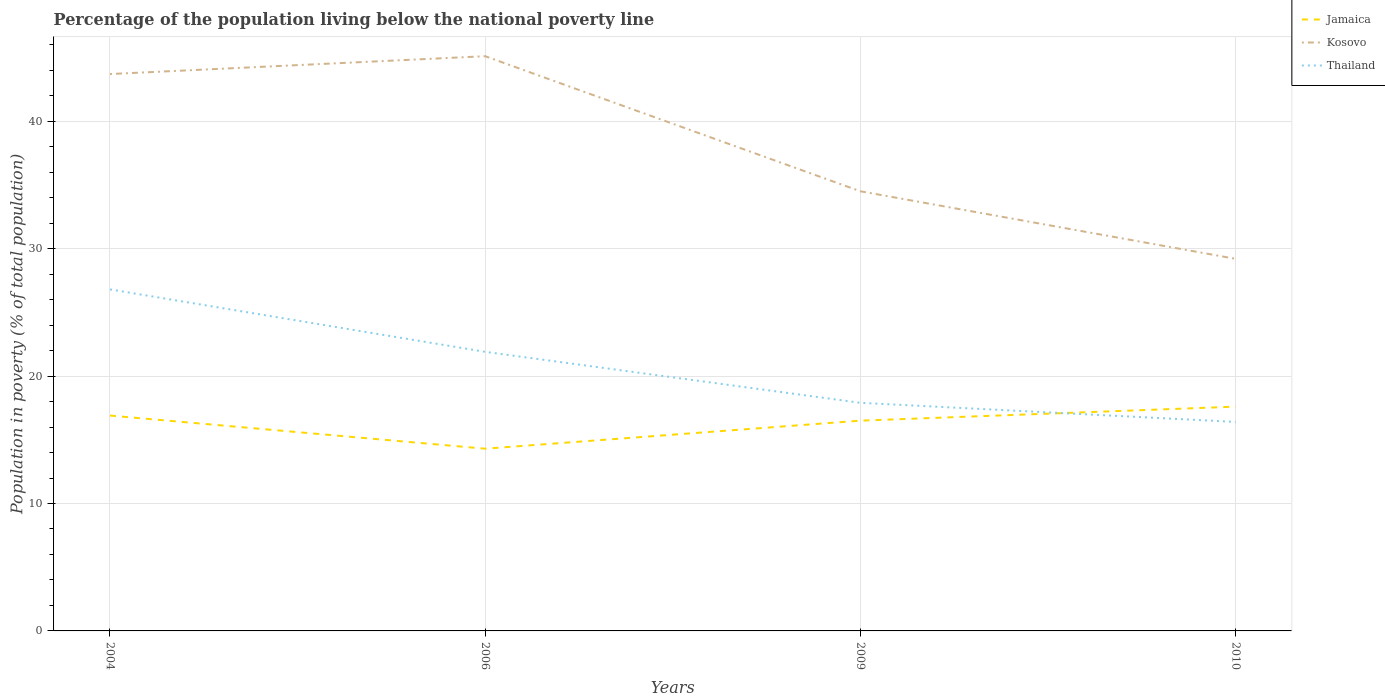How many different coloured lines are there?
Keep it short and to the point. 3. Does the line corresponding to Kosovo intersect with the line corresponding to Jamaica?
Provide a succinct answer. No. Is the number of lines equal to the number of legend labels?
Your response must be concise. Yes. What is the total percentage of the population living below the national poverty line in Thailand in the graph?
Your answer should be compact. 4.9. What is the difference between the highest and the second highest percentage of the population living below the national poverty line in Kosovo?
Provide a short and direct response. 15.9. What is the difference between the highest and the lowest percentage of the population living below the national poverty line in Kosovo?
Provide a succinct answer. 2. Is the percentage of the population living below the national poverty line in Jamaica strictly greater than the percentage of the population living below the national poverty line in Thailand over the years?
Ensure brevity in your answer.  No. How many lines are there?
Your answer should be compact. 3. How many years are there in the graph?
Make the answer very short. 4. Does the graph contain any zero values?
Make the answer very short. No. Does the graph contain grids?
Provide a succinct answer. Yes. Where does the legend appear in the graph?
Keep it short and to the point. Top right. How many legend labels are there?
Provide a short and direct response. 3. What is the title of the graph?
Offer a terse response. Percentage of the population living below the national poverty line. What is the label or title of the X-axis?
Your response must be concise. Years. What is the label or title of the Y-axis?
Make the answer very short. Population in poverty (% of total population). What is the Population in poverty (% of total population) of Kosovo in 2004?
Your answer should be compact. 43.7. What is the Population in poverty (% of total population) of Thailand in 2004?
Provide a succinct answer. 26.8. What is the Population in poverty (% of total population) of Kosovo in 2006?
Provide a succinct answer. 45.1. What is the Population in poverty (% of total population) in Thailand in 2006?
Your answer should be very brief. 21.9. What is the Population in poverty (% of total population) in Jamaica in 2009?
Provide a succinct answer. 16.5. What is the Population in poverty (% of total population) in Kosovo in 2009?
Make the answer very short. 34.5. What is the Population in poverty (% of total population) in Kosovo in 2010?
Ensure brevity in your answer.  29.2. Across all years, what is the maximum Population in poverty (% of total population) in Jamaica?
Keep it short and to the point. 17.6. Across all years, what is the maximum Population in poverty (% of total population) of Kosovo?
Offer a very short reply. 45.1. Across all years, what is the maximum Population in poverty (% of total population) of Thailand?
Make the answer very short. 26.8. Across all years, what is the minimum Population in poverty (% of total population) in Jamaica?
Keep it short and to the point. 14.3. Across all years, what is the minimum Population in poverty (% of total population) in Kosovo?
Offer a terse response. 29.2. Across all years, what is the minimum Population in poverty (% of total population) in Thailand?
Give a very brief answer. 16.4. What is the total Population in poverty (% of total population) of Jamaica in the graph?
Keep it short and to the point. 65.3. What is the total Population in poverty (% of total population) of Kosovo in the graph?
Offer a very short reply. 152.5. What is the difference between the Population in poverty (% of total population) of Jamaica in 2004 and that in 2006?
Your answer should be compact. 2.6. What is the difference between the Population in poverty (% of total population) of Kosovo in 2004 and that in 2009?
Offer a terse response. 9.2. What is the difference between the Population in poverty (% of total population) in Thailand in 2004 and that in 2009?
Keep it short and to the point. 8.9. What is the difference between the Population in poverty (% of total population) in Jamaica in 2004 and that in 2010?
Keep it short and to the point. -0.7. What is the difference between the Population in poverty (% of total population) of Kosovo in 2004 and that in 2010?
Ensure brevity in your answer.  14.5. What is the difference between the Population in poverty (% of total population) of Thailand in 2004 and that in 2010?
Your answer should be very brief. 10.4. What is the difference between the Population in poverty (% of total population) in Thailand in 2006 and that in 2009?
Your answer should be compact. 4. What is the difference between the Population in poverty (% of total population) in Kosovo in 2009 and that in 2010?
Provide a succinct answer. 5.3. What is the difference between the Population in poverty (% of total population) of Jamaica in 2004 and the Population in poverty (% of total population) of Kosovo in 2006?
Ensure brevity in your answer.  -28.2. What is the difference between the Population in poverty (% of total population) of Kosovo in 2004 and the Population in poverty (% of total population) of Thailand in 2006?
Provide a succinct answer. 21.8. What is the difference between the Population in poverty (% of total population) of Jamaica in 2004 and the Population in poverty (% of total population) of Kosovo in 2009?
Offer a terse response. -17.6. What is the difference between the Population in poverty (% of total population) of Jamaica in 2004 and the Population in poverty (% of total population) of Thailand in 2009?
Provide a succinct answer. -1. What is the difference between the Population in poverty (% of total population) in Kosovo in 2004 and the Population in poverty (% of total population) in Thailand in 2009?
Ensure brevity in your answer.  25.8. What is the difference between the Population in poverty (% of total population) in Jamaica in 2004 and the Population in poverty (% of total population) in Thailand in 2010?
Provide a short and direct response. 0.5. What is the difference between the Population in poverty (% of total population) of Kosovo in 2004 and the Population in poverty (% of total population) of Thailand in 2010?
Your answer should be compact. 27.3. What is the difference between the Population in poverty (% of total population) of Jamaica in 2006 and the Population in poverty (% of total population) of Kosovo in 2009?
Provide a short and direct response. -20.2. What is the difference between the Population in poverty (% of total population) in Kosovo in 2006 and the Population in poverty (% of total population) in Thailand in 2009?
Your response must be concise. 27.2. What is the difference between the Population in poverty (% of total population) in Jamaica in 2006 and the Population in poverty (% of total population) in Kosovo in 2010?
Your answer should be very brief. -14.9. What is the difference between the Population in poverty (% of total population) of Jamaica in 2006 and the Population in poverty (% of total population) of Thailand in 2010?
Ensure brevity in your answer.  -2.1. What is the difference between the Population in poverty (% of total population) in Kosovo in 2006 and the Population in poverty (% of total population) in Thailand in 2010?
Offer a very short reply. 28.7. What is the difference between the Population in poverty (% of total population) in Jamaica in 2009 and the Population in poverty (% of total population) in Thailand in 2010?
Provide a succinct answer. 0.1. What is the average Population in poverty (% of total population) of Jamaica per year?
Ensure brevity in your answer.  16.32. What is the average Population in poverty (% of total population) in Kosovo per year?
Your response must be concise. 38.12. What is the average Population in poverty (% of total population) of Thailand per year?
Offer a terse response. 20.75. In the year 2004, what is the difference between the Population in poverty (% of total population) of Jamaica and Population in poverty (% of total population) of Kosovo?
Your answer should be very brief. -26.8. In the year 2006, what is the difference between the Population in poverty (% of total population) in Jamaica and Population in poverty (% of total population) in Kosovo?
Give a very brief answer. -30.8. In the year 2006, what is the difference between the Population in poverty (% of total population) of Kosovo and Population in poverty (% of total population) of Thailand?
Ensure brevity in your answer.  23.2. In the year 2009, what is the difference between the Population in poverty (% of total population) in Jamaica and Population in poverty (% of total population) in Kosovo?
Provide a succinct answer. -18. In the year 2009, what is the difference between the Population in poverty (% of total population) of Jamaica and Population in poverty (% of total population) of Thailand?
Offer a very short reply. -1.4. In the year 2010, what is the difference between the Population in poverty (% of total population) of Jamaica and Population in poverty (% of total population) of Kosovo?
Your answer should be very brief. -11.6. In the year 2010, what is the difference between the Population in poverty (% of total population) in Kosovo and Population in poverty (% of total population) in Thailand?
Give a very brief answer. 12.8. What is the ratio of the Population in poverty (% of total population) in Jamaica in 2004 to that in 2006?
Give a very brief answer. 1.18. What is the ratio of the Population in poverty (% of total population) in Kosovo in 2004 to that in 2006?
Your answer should be compact. 0.97. What is the ratio of the Population in poverty (% of total population) in Thailand in 2004 to that in 2006?
Your answer should be very brief. 1.22. What is the ratio of the Population in poverty (% of total population) in Jamaica in 2004 to that in 2009?
Offer a very short reply. 1.02. What is the ratio of the Population in poverty (% of total population) of Kosovo in 2004 to that in 2009?
Your response must be concise. 1.27. What is the ratio of the Population in poverty (% of total population) in Thailand in 2004 to that in 2009?
Your response must be concise. 1.5. What is the ratio of the Population in poverty (% of total population) of Jamaica in 2004 to that in 2010?
Offer a terse response. 0.96. What is the ratio of the Population in poverty (% of total population) in Kosovo in 2004 to that in 2010?
Offer a terse response. 1.5. What is the ratio of the Population in poverty (% of total population) of Thailand in 2004 to that in 2010?
Offer a very short reply. 1.63. What is the ratio of the Population in poverty (% of total population) in Jamaica in 2006 to that in 2009?
Offer a terse response. 0.87. What is the ratio of the Population in poverty (% of total population) of Kosovo in 2006 to that in 2009?
Offer a terse response. 1.31. What is the ratio of the Population in poverty (% of total population) in Thailand in 2006 to that in 2009?
Give a very brief answer. 1.22. What is the ratio of the Population in poverty (% of total population) in Jamaica in 2006 to that in 2010?
Your answer should be very brief. 0.81. What is the ratio of the Population in poverty (% of total population) of Kosovo in 2006 to that in 2010?
Offer a terse response. 1.54. What is the ratio of the Population in poverty (% of total population) in Thailand in 2006 to that in 2010?
Offer a terse response. 1.34. What is the ratio of the Population in poverty (% of total population) in Kosovo in 2009 to that in 2010?
Ensure brevity in your answer.  1.18. What is the ratio of the Population in poverty (% of total population) of Thailand in 2009 to that in 2010?
Your answer should be compact. 1.09. What is the difference between the highest and the second highest Population in poverty (% of total population) in Kosovo?
Provide a short and direct response. 1.4. What is the difference between the highest and the lowest Population in poverty (% of total population) of Kosovo?
Your answer should be very brief. 15.9. What is the difference between the highest and the lowest Population in poverty (% of total population) of Thailand?
Give a very brief answer. 10.4. 